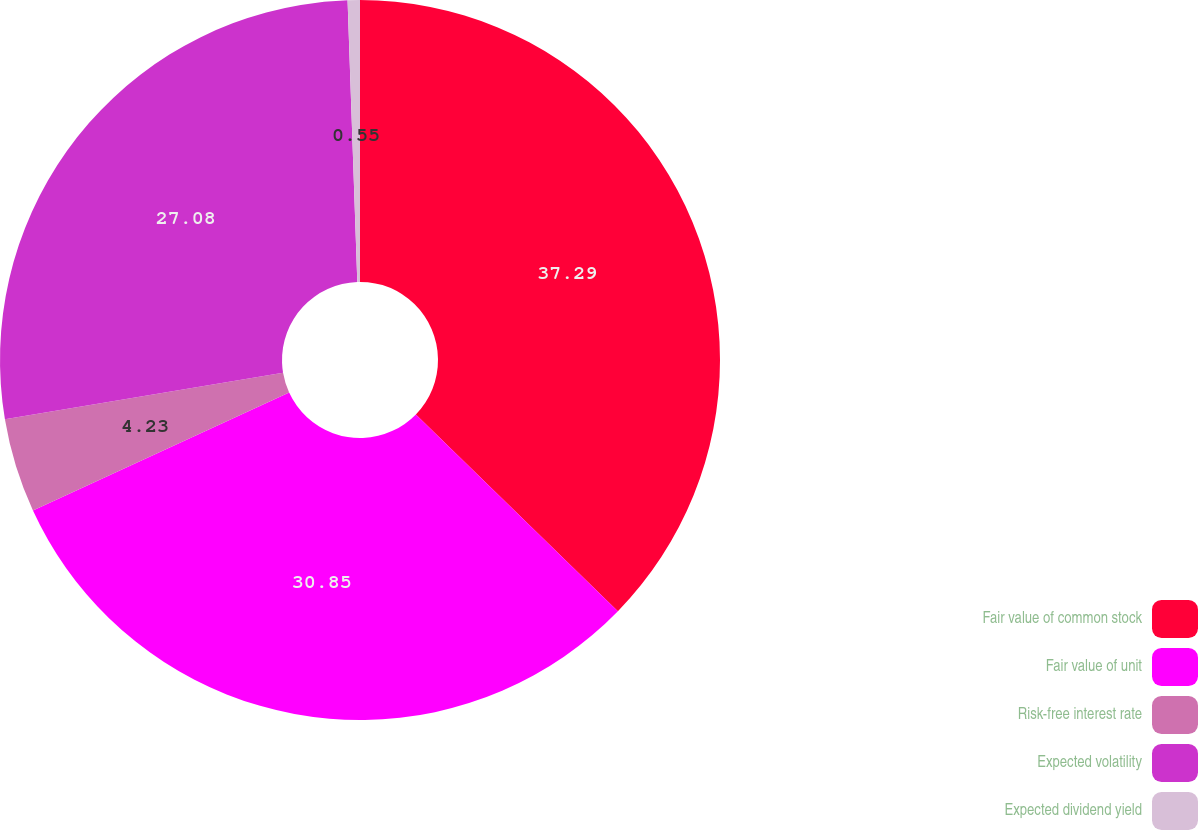Convert chart to OTSL. <chart><loc_0><loc_0><loc_500><loc_500><pie_chart><fcel>Fair value of common stock<fcel>Fair value of unit<fcel>Risk-free interest rate<fcel>Expected volatility<fcel>Expected dividend yield<nl><fcel>37.29%<fcel>30.85%<fcel>4.23%<fcel>27.08%<fcel>0.55%<nl></chart> 